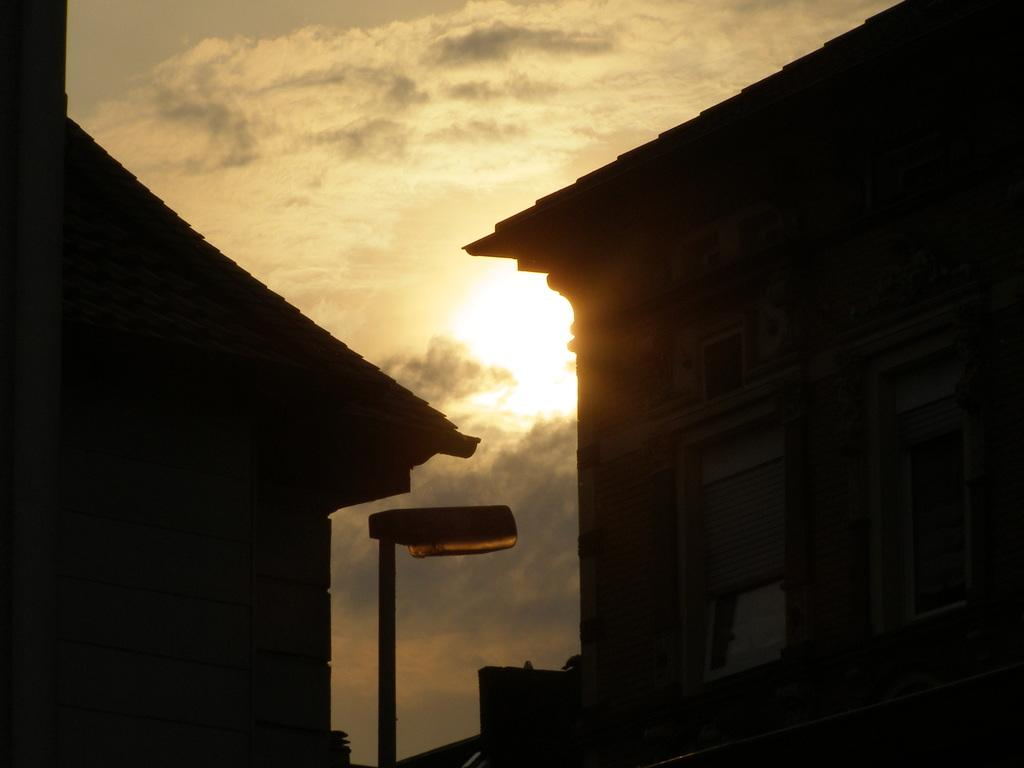What type of structures can be seen in the image? There are buildings in the image. What object is present in the image besides the buildings? There is a pole in the image. What can be seen in the background of the image? The sky is visible in the background of the image. How would you describe the weather based on the appearance of the sky? The sky appears to be cloudy, which might suggest overcast or potentially rainy weather. How many buttons can be seen on the plate in the image? There is no plate or buttons present in the image. Can you describe the frogs' behavior in the image? There are no frogs present in the image. 